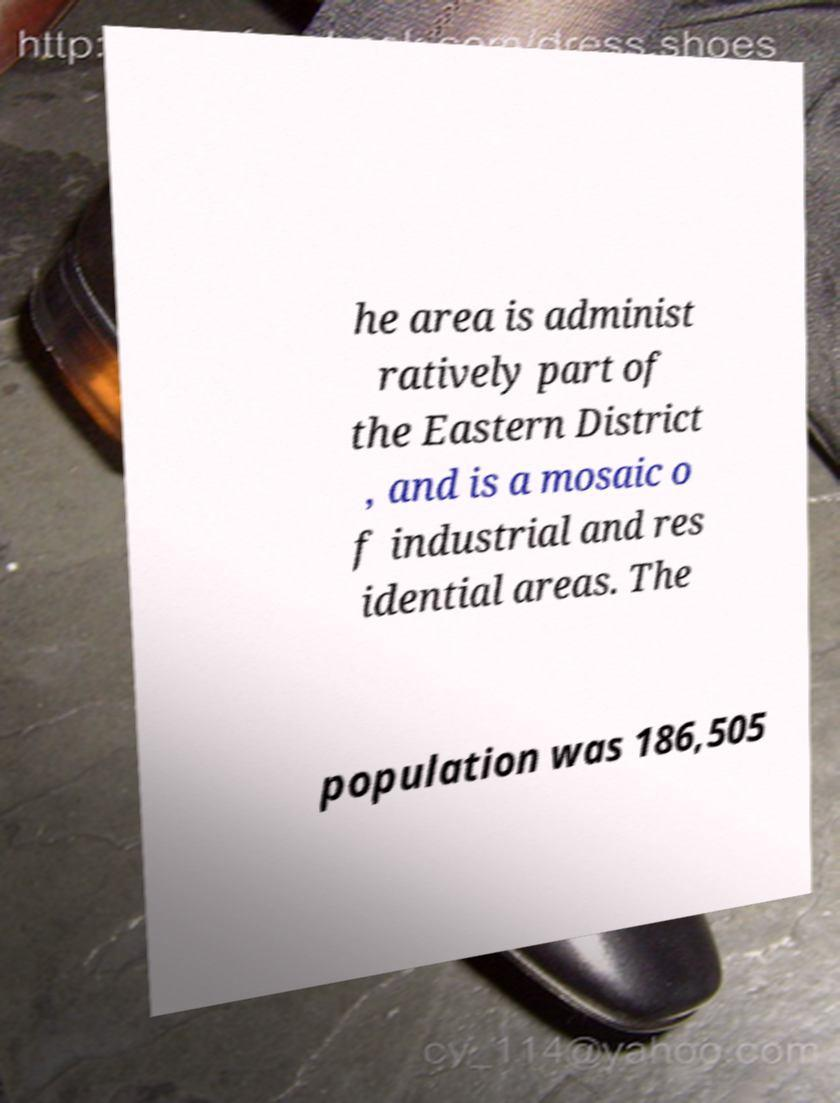There's text embedded in this image that I need extracted. Can you transcribe it verbatim? he area is administ ratively part of the Eastern District , and is a mosaic o f industrial and res idential areas. The population was 186,505 